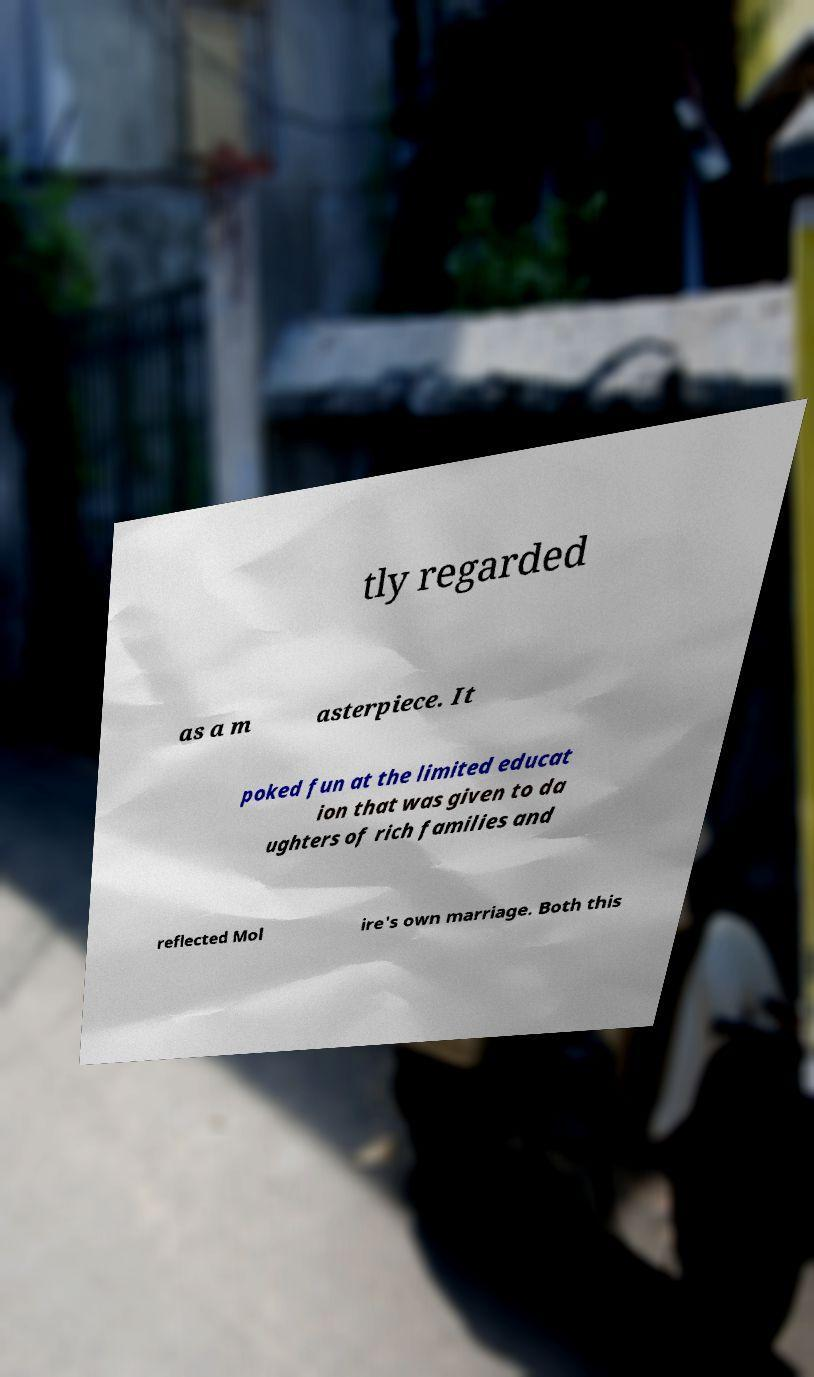Could you assist in decoding the text presented in this image and type it out clearly? tly regarded as a m asterpiece. It poked fun at the limited educat ion that was given to da ughters of rich families and reflected Mol ire's own marriage. Both this 